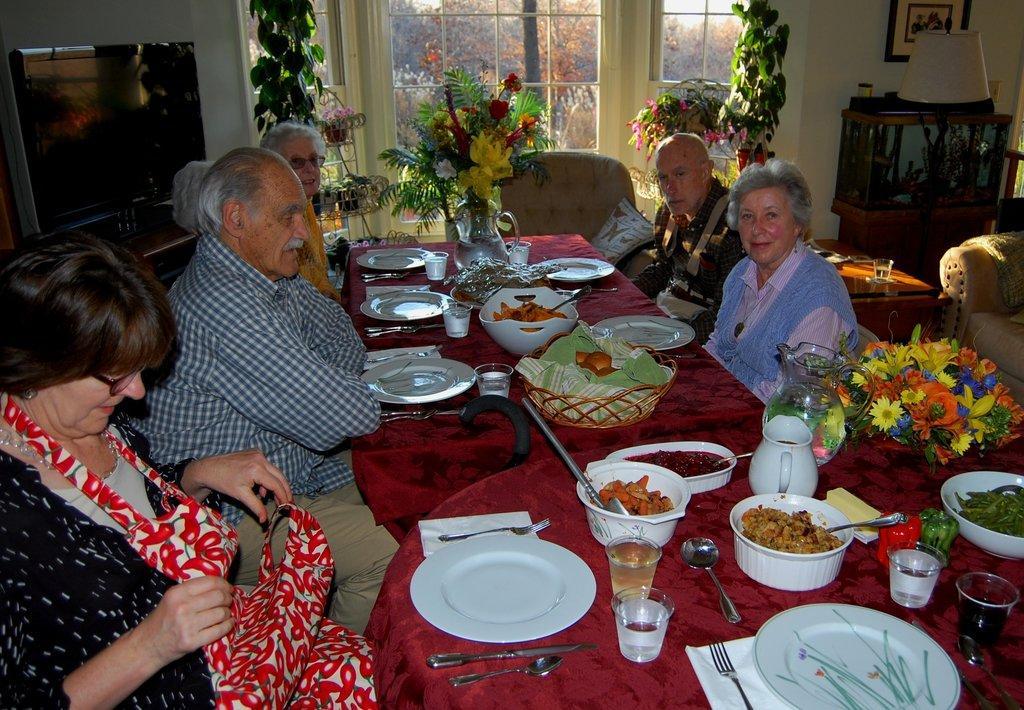Could you give a brief overview of what you see in this image? A family is sitting at a dining table and about to have their food. 